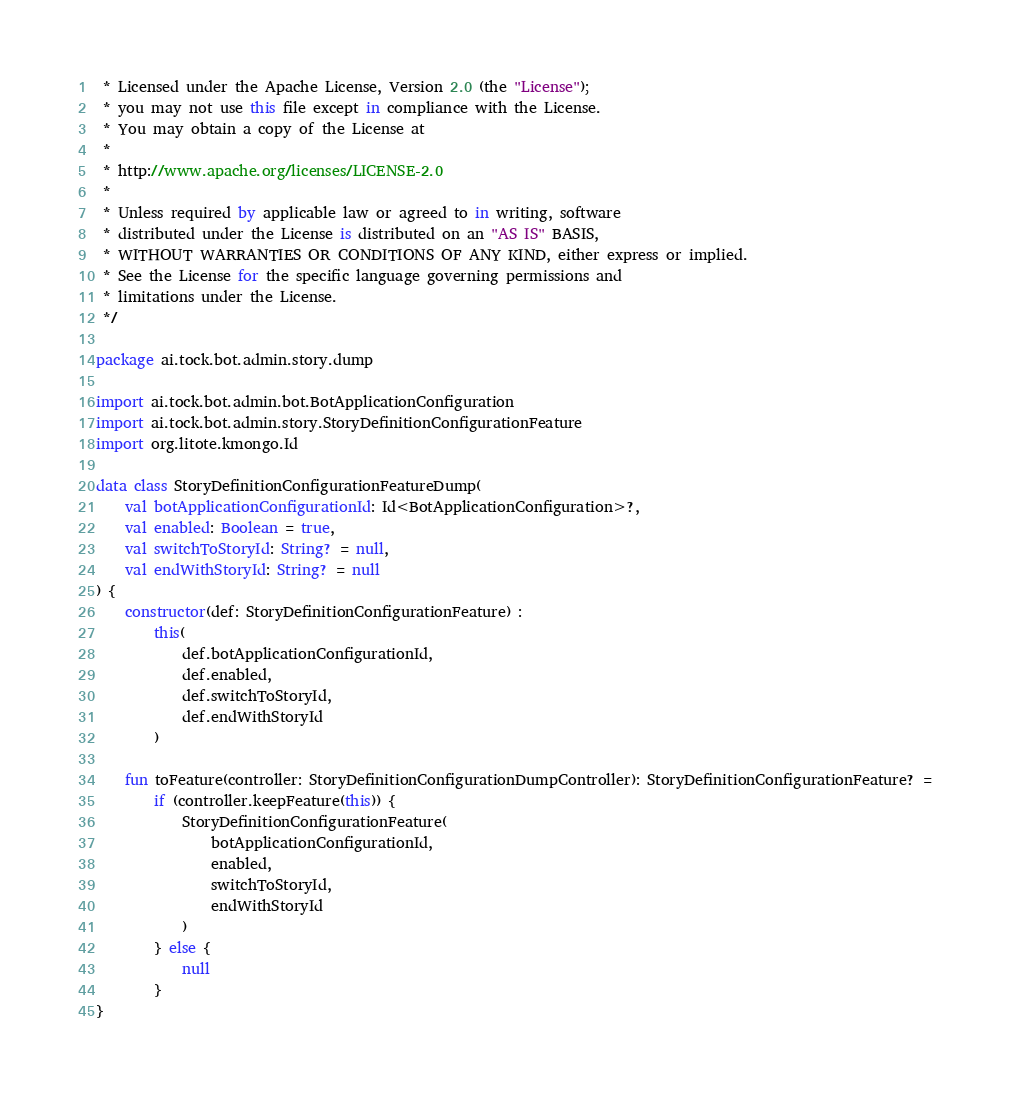<code> <loc_0><loc_0><loc_500><loc_500><_Kotlin_> * Licensed under the Apache License, Version 2.0 (the "License");
 * you may not use this file except in compliance with the License.
 * You may obtain a copy of the License at
 *
 * http://www.apache.org/licenses/LICENSE-2.0
 *
 * Unless required by applicable law or agreed to in writing, software
 * distributed under the License is distributed on an "AS IS" BASIS,
 * WITHOUT WARRANTIES OR CONDITIONS OF ANY KIND, either express or implied.
 * See the License for the specific language governing permissions and
 * limitations under the License.
 */

package ai.tock.bot.admin.story.dump

import ai.tock.bot.admin.bot.BotApplicationConfiguration
import ai.tock.bot.admin.story.StoryDefinitionConfigurationFeature
import org.litote.kmongo.Id

data class StoryDefinitionConfigurationFeatureDump(
    val botApplicationConfigurationId: Id<BotApplicationConfiguration>?,
    val enabled: Boolean = true,
    val switchToStoryId: String? = null,
    val endWithStoryId: String? = null
) {
    constructor(def: StoryDefinitionConfigurationFeature) :
        this(
            def.botApplicationConfigurationId,
            def.enabled,
            def.switchToStoryId,
            def.endWithStoryId
        )

    fun toFeature(controller: StoryDefinitionConfigurationDumpController): StoryDefinitionConfigurationFeature? =
        if (controller.keepFeature(this)) {
            StoryDefinitionConfigurationFeature(
                botApplicationConfigurationId,
                enabled,
                switchToStoryId,
                endWithStoryId
            )
        } else {
            null
        }
}</code> 